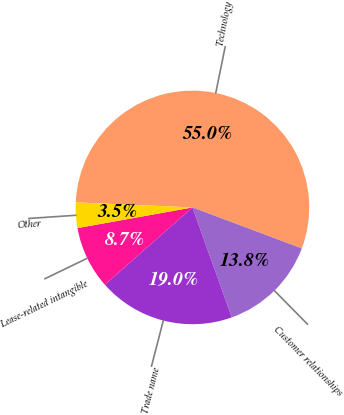<chart> <loc_0><loc_0><loc_500><loc_500><pie_chart><fcel>Technology<fcel>Customer relationships<fcel>Trade name<fcel>Lease-related intangible<fcel>Other<nl><fcel>55.02%<fcel>13.82%<fcel>18.97%<fcel>8.67%<fcel>3.52%<nl></chart> 